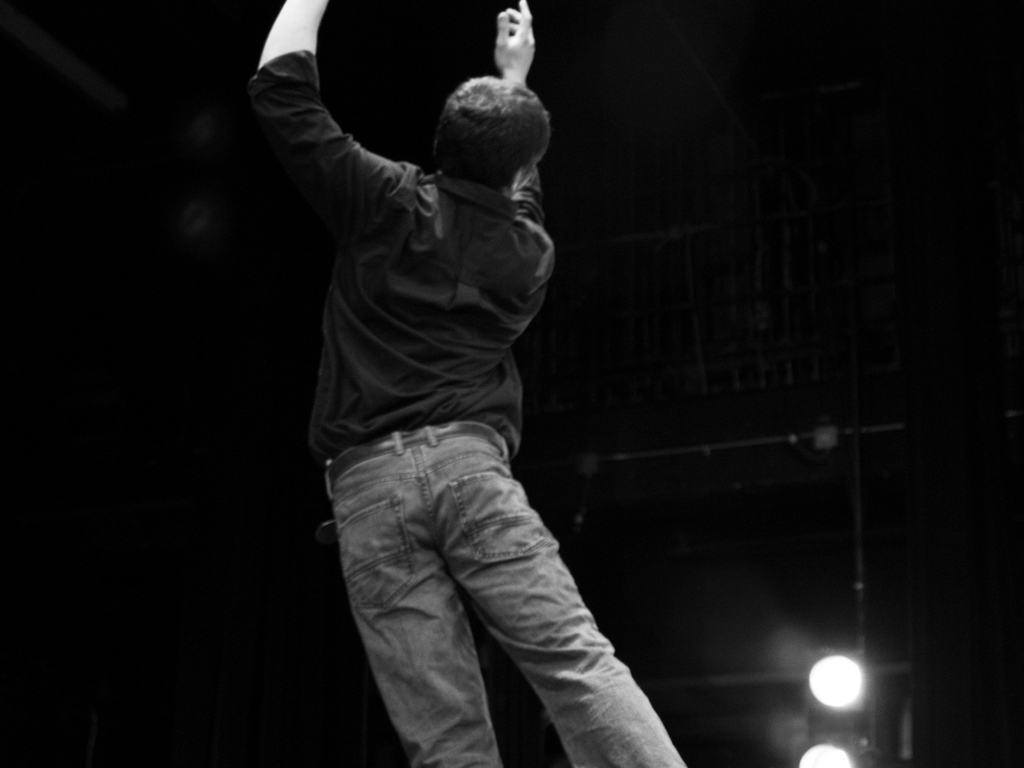What is the overall mood conveyed by this image? The image exudes a sense of dramatic tension and focus, likely from a performance or an event where attention is centered on an individual's actions or expressions. Can you describe the setting of this image? The setting appears to be a dimly lit stage with spotlights, typically indicative of a theater or performance venue, suggesting that the person might be an actor or a dancer mid-performance. 